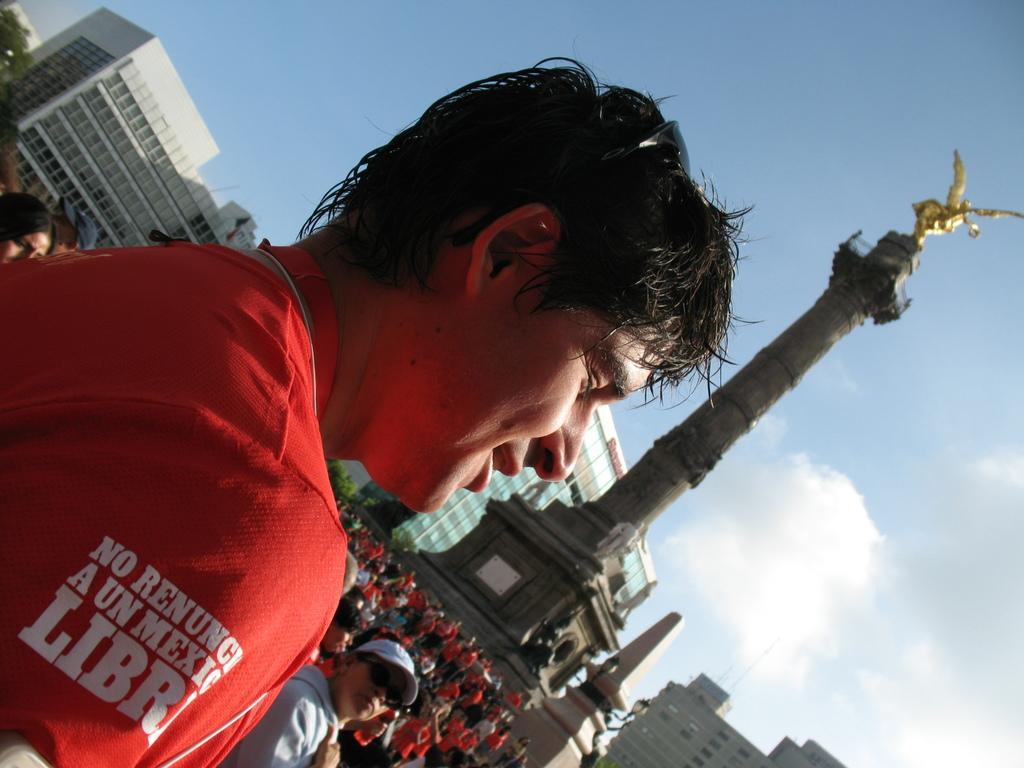In one or two sentences, can you explain what this image depicts? In this image we can see a man wearing a red shirt. In the background there are people and we can see buildings. In the center there is a tower. At the top there is sky. 